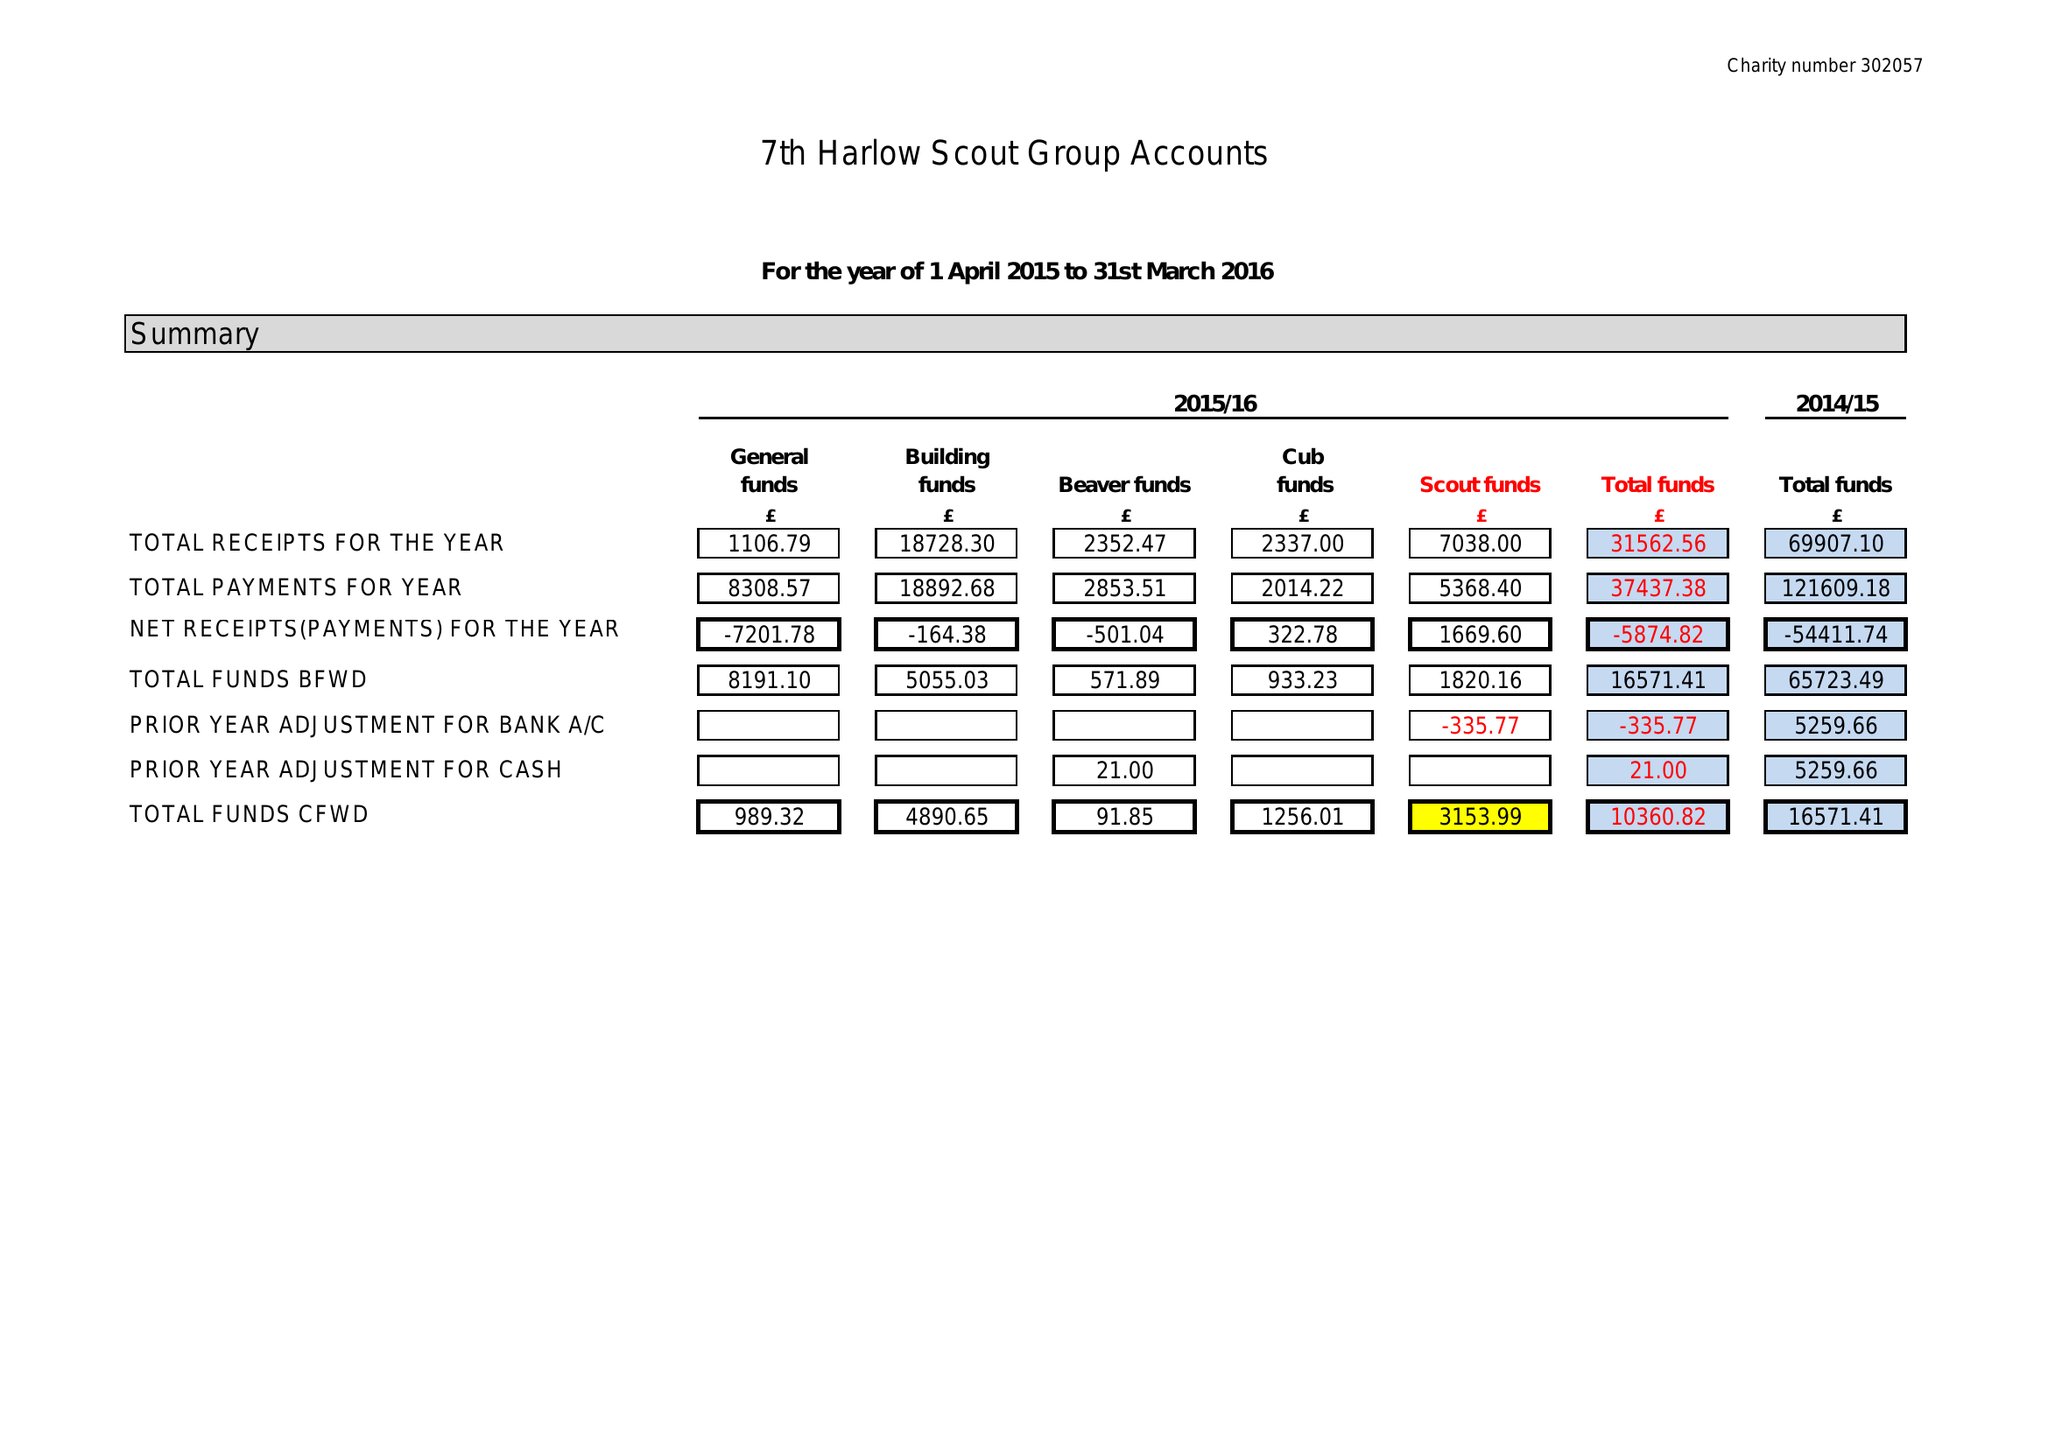What is the value for the address__post_town?
Answer the question using a single word or phrase. HARLOW 